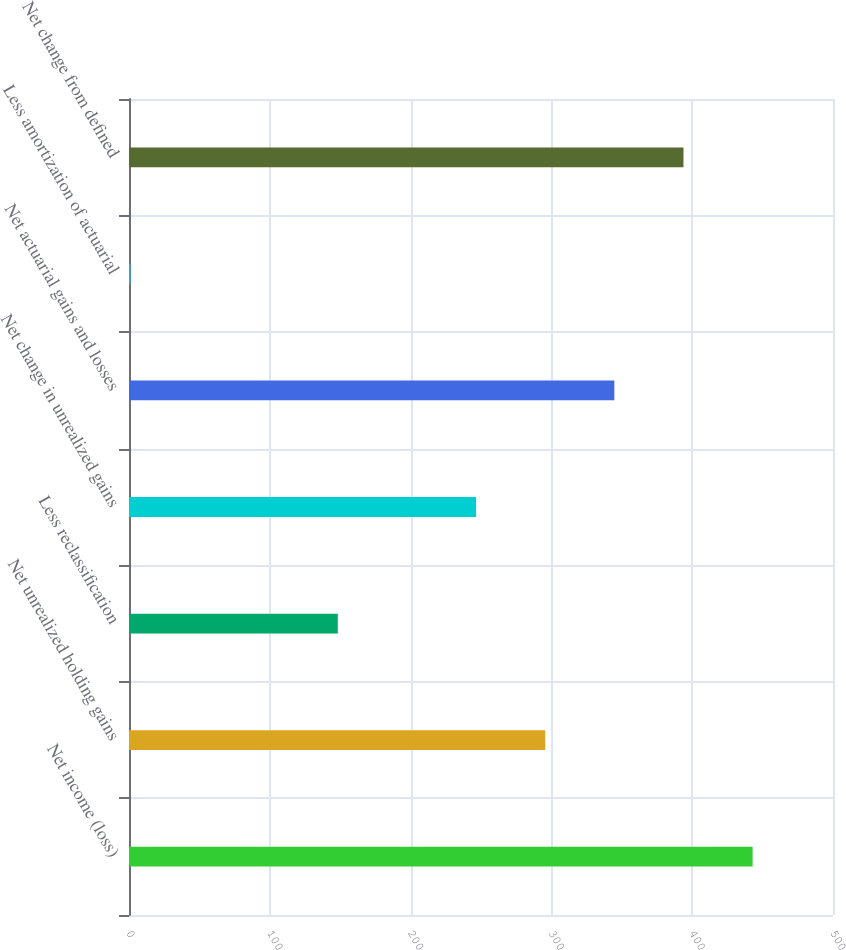Convert chart. <chart><loc_0><loc_0><loc_500><loc_500><bar_chart><fcel>Net income (loss)<fcel>Net unrealized holding gains<fcel>Less reclassification<fcel>Net change in unrealized gains<fcel>Net actuarial gains and losses<fcel>Less amortization of actuarial<fcel>Net change from defined<nl><fcel>442.9<fcel>295.6<fcel>148.3<fcel>246.5<fcel>344.7<fcel>1<fcel>393.8<nl></chart> 